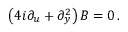Convert formula to latex. <formula><loc_0><loc_0><loc_500><loc_500>\left ( 4 i \partial _ { u } + \partial _ { y } ^ { 2 } \right ) B = 0 \, .</formula> 